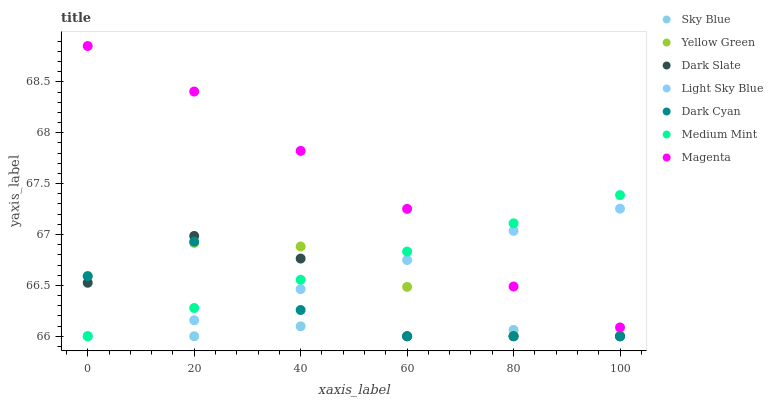Does Sky Blue have the minimum area under the curve?
Answer yes or no. Yes. Does Magenta have the maximum area under the curve?
Answer yes or no. Yes. Does Yellow Green have the minimum area under the curve?
Answer yes or no. No. Does Yellow Green have the maximum area under the curve?
Answer yes or no. No. Is Medium Mint the smoothest?
Answer yes or no. Yes. Is Dark Slate the roughest?
Answer yes or no. Yes. Is Yellow Green the smoothest?
Answer yes or no. No. Is Yellow Green the roughest?
Answer yes or no. No. Does Medium Mint have the lowest value?
Answer yes or no. Yes. Does Magenta have the lowest value?
Answer yes or no. No. Does Magenta have the highest value?
Answer yes or no. Yes. Does Yellow Green have the highest value?
Answer yes or no. No. Is Sky Blue less than Magenta?
Answer yes or no. Yes. Is Magenta greater than Dark Slate?
Answer yes or no. Yes. Does Yellow Green intersect Dark Cyan?
Answer yes or no. Yes. Is Yellow Green less than Dark Cyan?
Answer yes or no. No. Is Yellow Green greater than Dark Cyan?
Answer yes or no. No. Does Sky Blue intersect Magenta?
Answer yes or no. No. 